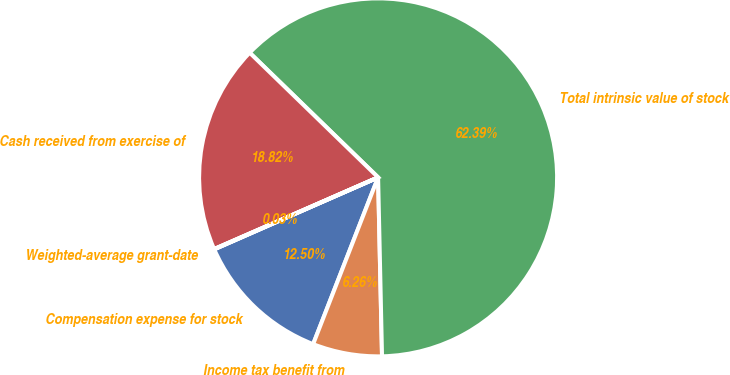Convert chart. <chart><loc_0><loc_0><loc_500><loc_500><pie_chart><fcel>Compensation expense for stock<fcel>Income tax benefit from<fcel>Total intrinsic value of stock<fcel>Cash received from exercise of<fcel>Weighted-average grant-date<nl><fcel>12.5%<fcel>6.26%<fcel>62.39%<fcel>18.82%<fcel>0.03%<nl></chart> 